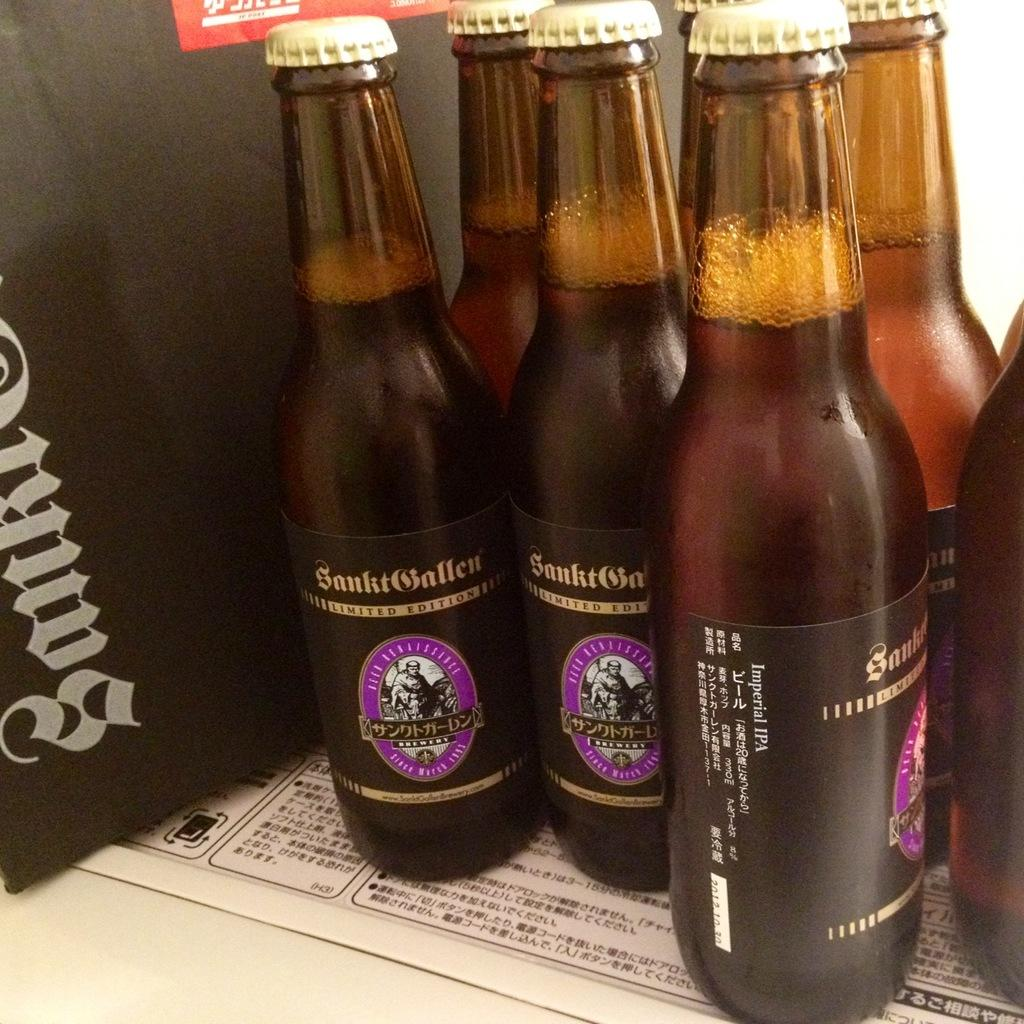<image>
Provide a brief description of the given image. Bottles of Imperial IPA sit crowded together on a table. 